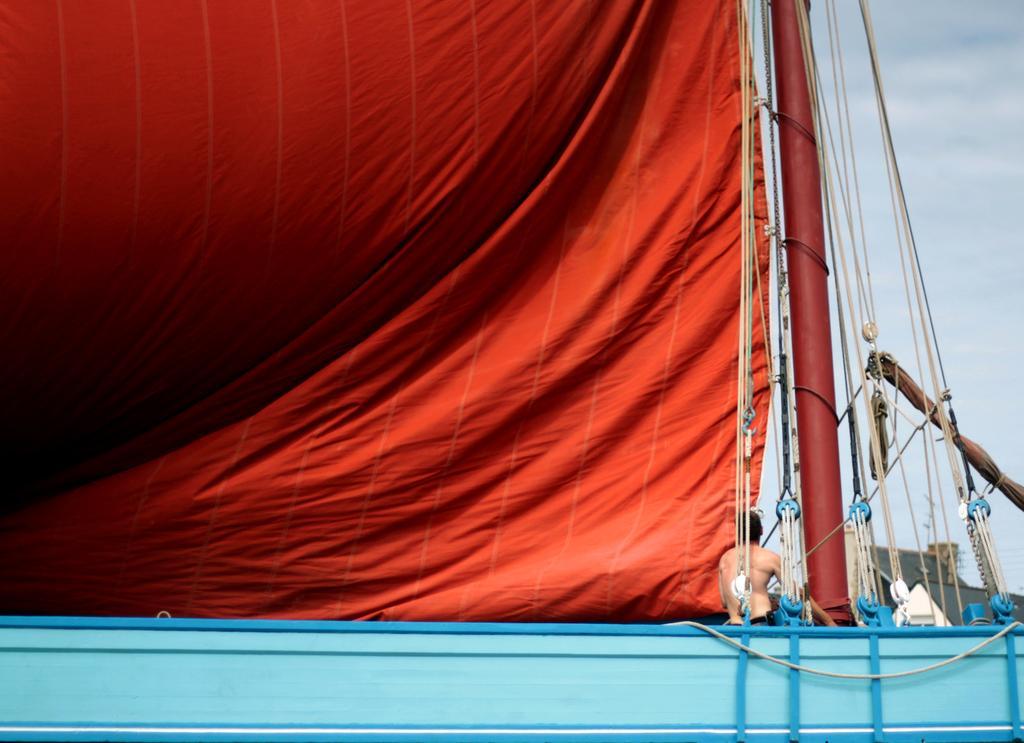How would you summarize this image in a sentence or two? Sky is cloudy. Here we can see a person and red cloth. 